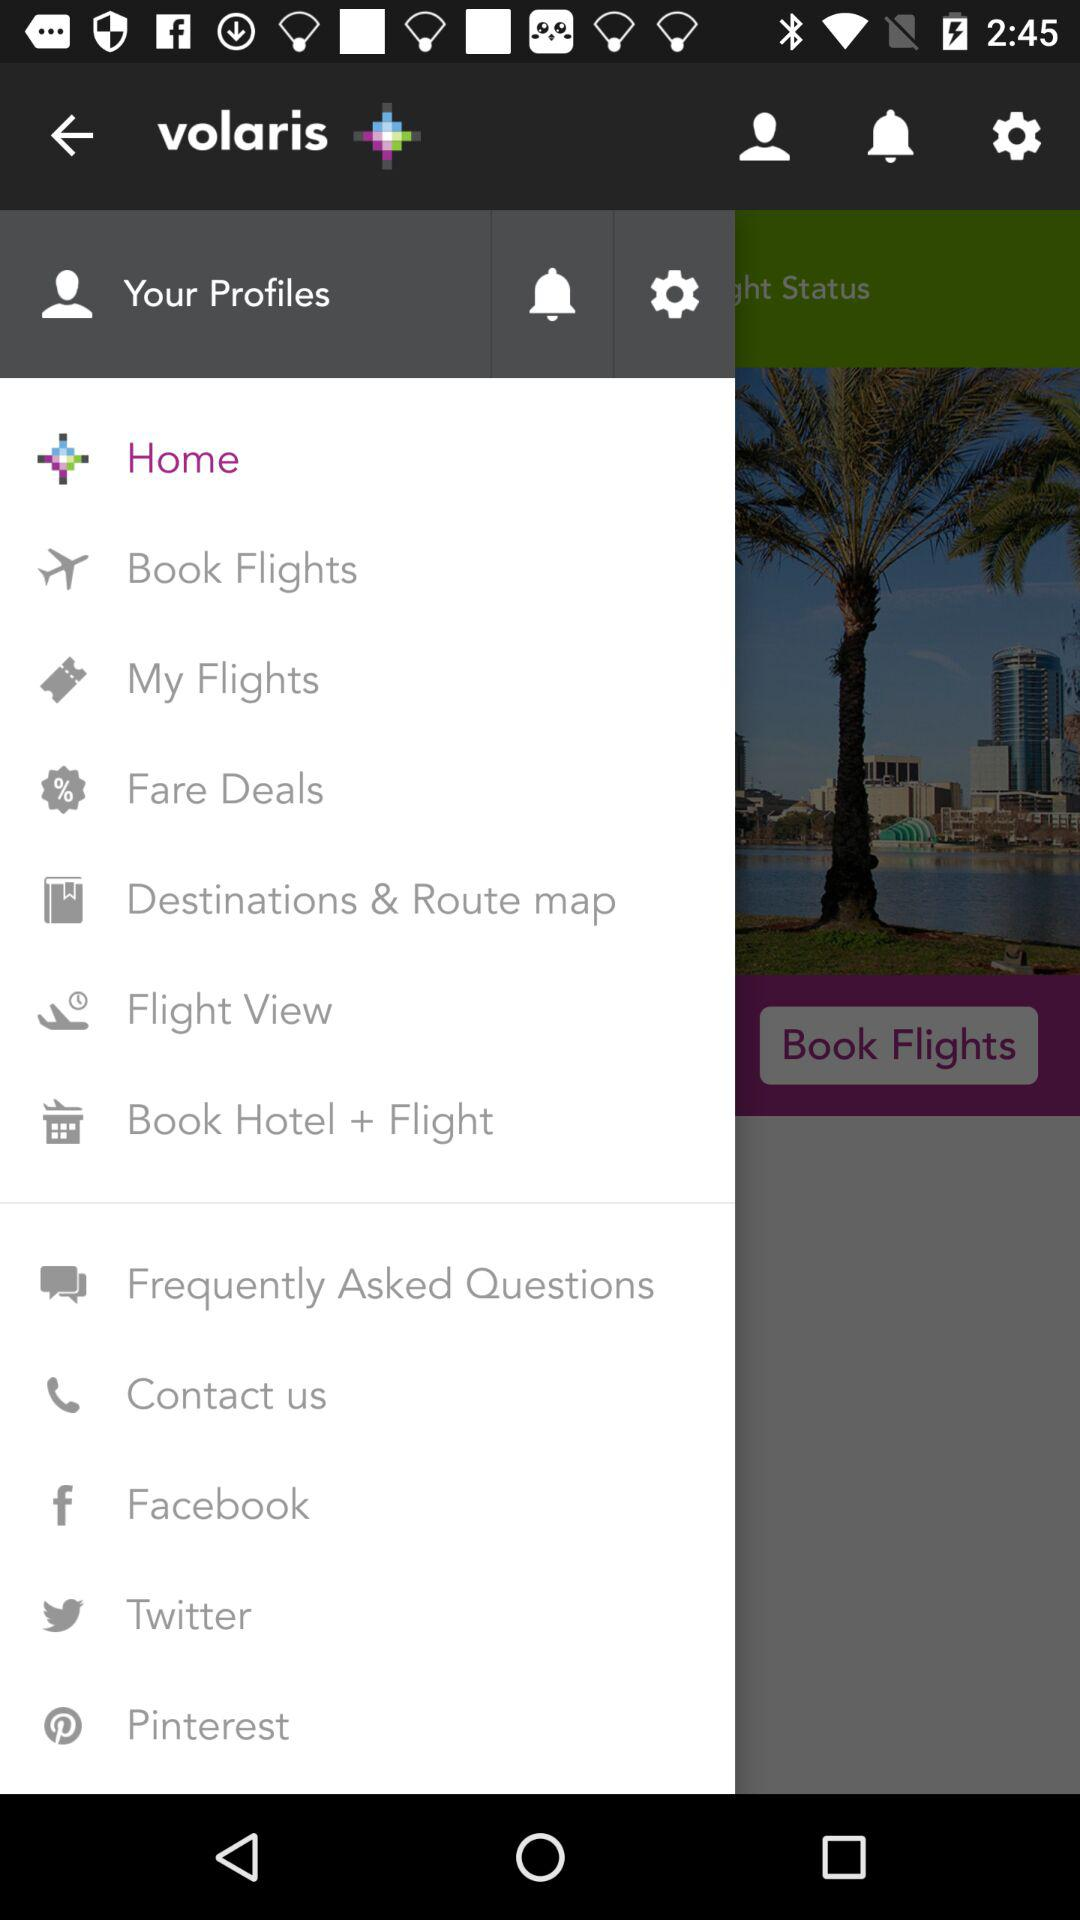Which flights have been booked?
When the provided information is insufficient, respond with <no answer>. <no answer> 